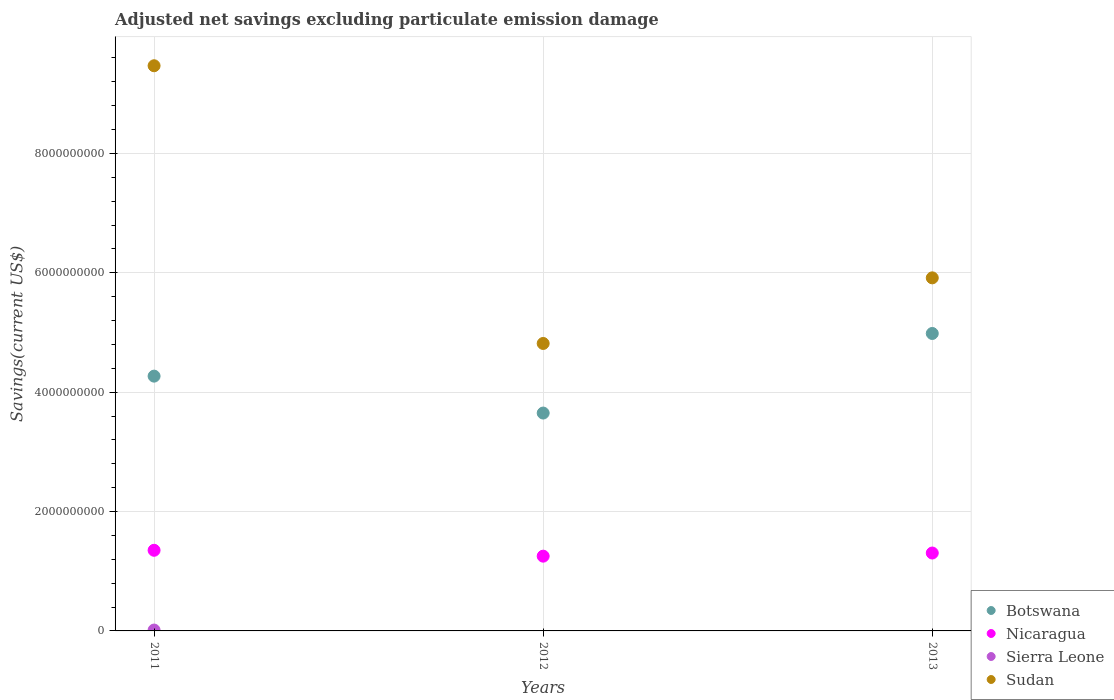How many different coloured dotlines are there?
Ensure brevity in your answer.  4. What is the adjusted net savings in Sierra Leone in 2011?
Offer a very short reply. 1.45e+07. Across all years, what is the maximum adjusted net savings in Sierra Leone?
Your answer should be very brief. 1.45e+07. Across all years, what is the minimum adjusted net savings in Sierra Leone?
Provide a succinct answer. 0. What is the total adjusted net savings in Nicaragua in the graph?
Offer a very short reply. 3.91e+09. What is the difference between the adjusted net savings in Nicaragua in 2011 and that in 2013?
Provide a short and direct response. 4.59e+07. What is the difference between the adjusted net savings in Botswana in 2011 and the adjusted net savings in Sierra Leone in 2013?
Your response must be concise. 4.27e+09. What is the average adjusted net savings in Sierra Leone per year?
Your answer should be compact. 4.82e+06. In the year 2013, what is the difference between the adjusted net savings in Sudan and adjusted net savings in Botswana?
Offer a very short reply. 9.32e+08. What is the ratio of the adjusted net savings in Botswana in 2011 to that in 2012?
Offer a very short reply. 1.17. What is the difference between the highest and the second highest adjusted net savings in Sudan?
Ensure brevity in your answer.  3.55e+09. What is the difference between the highest and the lowest adjusted net savings in Sierra Leone?
Give a very brief answer. 1.45e+07. Is it the case that in every year, the sum of the adjusted net savings in Botswana and adjusted net savings in Sudan  is greater than the sum of adjusted net savings in Sierra Leone and adjusted net savings in Nicaragua?
Offer a terse response. No. Is it the case that in every year, the sum of the adjusted net savings in Sierra Leone and adjusted net savings in Nicaragua  is greater than the adjusted net savings in Botswana?
Offer a very short reply. No. Does the adjusted net savings in Sierra Leone monotonically increase over the years?
Offer a terse response. No. How many dotlines are there?
Your answer should be very brief. 4. How many years are there in the graph?
Your answer should be compact. 3. Does the graph contain any zero values?
Your answer should be very brief. Yes. Does the graph contain grids?
Your response must be concise. Yes. Where does the legend appear in the graph?
Your response must be concise. Bottom right. How are the legend labels stacked?
Provide a succinct answer. Vertical. What is the title of the graph?
Make the answer very short. Adjusted net savings excluding particulate emission damage. Does "Belize" appear as one of the legend labels in the graph?
Your answer should be compact. No. What is the label or title of the X-axis?
Your answer should be very brief. Years. What is the label or title of the Y-axis?
Give a very brief answer. Savings(current US$). What is the Savings(current US$) in Botswana in 2011?
Offer a very short reply. 4.27e+09. What is the Savings(current US$) in Nicaragua in 2011?
Offer a terse response. 1.35e+09. What is the Savings(current US$) of Sierra Leone in 2011?
Offer a very short reply. 1.45e+07. What is the Savings(current US$) of Sudan in 2011?
Offer a very short reply. 9.47e+09. What is the Savings(current US$) of Botswana in 2012?
Your answer should be very brief. 3.65e+09. What is the Savings(current US$) of Nicaragua in 2012?
Keep it short and to the point. 1.25e+09. What is the Savings(current US$) of Sudan in 2012?
Your response must be concise. 4.82e+09. What is the Savings(current US$) of Botswana in 2013?
Keep it short and to the point. 4.98e+09. What is the Savings(current US$) of Nicaragua in 2013?
Offer a very short reply. 1.31e+09. What is the Savings(current US$) in Sudan in 2013?
Your answer should be very brief. 5.91e+09. Across all years, what is the maximum Savings(current US$) of Botswana?
Your response must be concise. 4.98e+09. Across all years, what is the maximum Savings(current US$) in Nicaragua?
Your answer should be compact. 1.35e+09. Across all years, what is the maximum Savings(current US$) of Sierra Leone?
Provide a succinct answer. 1.45e+07. Across all years, what is the maximum Savings(current US$) of Sudan?
Offer a very short reply. 9.47e+09. Across all years, what is the minimum Savings(current US$) of Botswana?
Make the answer very short. 3.65e+09. Across all years, what is the minimum Savings(current US$) in Nicaragua?
Your answer should be very brief. 1.25e+09. Across all years, what is the minimum Savings(current US$) in Sudan?
Offer a terse response. 4.82e+09. What is the total Savings(current US$) of Botswana in the graph?
Provide a succinct answer. 1.29e+1. What is the total Savings(current US$) of Nicaragua in the graph?
Make the answer very short. 3.91e+09. What is the total Savings(current US$) of Sierra Leone in the graph?
Your response must be concise. 1.45e+07. What is the total Savings(current US$) of Sudan in the graph?
Make the answer very short. 2.02e+1. What is the difference between the Savings(current US$) of Botswana in 2011 and that in 2012?
Your answer should be very brief. 6.19e+08. What is the difference between the Savings(current US$) in Nicaragua in 2011 and that in 2012?
Your answer should be compact. 9.85e+07. What is the difference between the Savings(current US$) in Sudan in 2011 and that in 2012?
Provide a short and direct response. 4.65e+09. What is the difference between the Savings(current US$) in Botswana in 2011 and that in 2013?
Give a very brief answer. -7.15e+08. What is the difference between the Savings(current US$) in Nicaragua in 2011 and that in 2013?
Provide a succinct answer. 4.59e+07. What is the difference between the Savings(current US$) in Sudan in 2011 and that in 2013?
Keep it short and to the point. 3.55e+09. What is the difference between the Savings(current US$) of Botswana in 2012 and that in 2013?
Offer a terse response. -1.33e+09. What is the difference between the Savings(current US$) in Nicaragua in 2012 and that in 2013?
Your answer should be very brief. -5.27e+07. What is the difference between the Savings(current US$) of Sudan in 2012 and that in 2013?
Offer a terse response. -1.10e+09. What is the difference between the Savings(current US$) in Botswana in 2011 and the Savings(current US$) in Nicaragua in 2012?
Your answer should be compact. 3.02e+09. What is the difference between the Savings(current US$) of Botswana in 2011 and the Savings(current US$) of Sudan in 2012?
Make the answer very short. -5.47e+08. What is the difference between the Savings(current US$) of Nicaragua in 2011 and the Savings(current US$) of Sudan in 2012?
Offer a terse response. -3.46e+09. What is the difference between the Savings(current US$) in Sierra Leone in 2011 and the Savings(current US$) in Sudan in 2012?
Give a very brief answer. -4.80e+09. What is the difference between the Savings(current US$) in Botswana in 2011 and the Savings(current US$) in Nicaragua in 2013?
Make the answer very short. 2.96e+09. What is the difference between the Savings(current US$) of Botswana in 2011 and the Savings(current US$) of Sudan in 2013?
Make the answer very short. -1.65e+09. What is the difference between the Savings(current US$) in Nicaragua in 2011 and the Savings(current US$) in Sudan in 2013?
Offer a terse response. -4.56e+09. What is the difference between the Savings(current US$) of Sierra Leone in 2011 and the Savings(current US$) of Sudan in 2013?
Give a very brief answer. -5.90e+09. What is the difference between the Savings(current US$) of Botswana in 2012 and the Savings(current US$) of Nicaragua in 2013?
Your answer should be compact. 2.34e+09. What is the difference between the Savings(current US$) of Botswana in 2012 and the Savings(current US$) of Sudan in 2013?
Provide a short and direct response. -2.27e+09. What is the difference between the Savings(current US$) in Nicaragua in 2012 and the Savings(current US$) in Sudan in 2013?
Your answer should be compact. -4.66e+09. What is the average Savings(current US$) in Botswana per year?
Give a very brief answer. 4.30e+09. What is the average Savings(current US$) in Nicaragua per year?
Ensure brevity in your answer.  1.30e+09. What is the average Savings(current US$) in Sierra Leone per year?
Provide a short and direct response. 4.82e+06. What is the average Savings(current US$) of Sudan per year?
Offer a terse response. 6.73e+09. In the year 2011, what is the difference between the Savings(current US$) in Botswana and Savings(current US$) in Nicaragua?
Your answer should be compact. 2.92e+09. In the year 2011, what is the difference between the Savings(current US$) in Botswana and Savings(current US$) in Sierra Leone?
Make the answer very short. 4.25e+09. In the year 2011, what is the difference between the Savings(current US$) of Botswana and Savings(current US$) of Sudan?
Provide a short and direct response. -5.20e+09. In the year 2011, what is the difference between the Savings(current US$) in Nicaragua and Savings(current US$) in Sierra Leone?
Make the answer very short. 1.34e+09. In the year 2011, what is the difference between the Savings(current US$) in Nicaragua and Savings(current US$) in Sudan?
Make the answer very short. -8.12e+09. In the year 2011, what is the difference between the Savings(current US$) in Sierra Leone and Savings(current US$) in Sudan?
Offer a very short reply. -9.45e+09. In the year 2012, what is the difference between the Savings(current US$) in Botswana and Savings(current US$) in Nicaragua?
Ensure brevity in your answer.  2.40e+09. In the year 2012, what is the difference between the Savings(current US$) of Botswana and Savings(current US$) of Sudan?
Offer a terse response. -1.17e+09. In the year 2012, what is the difference between the Savings(current US$) of Nicaragua and Savings(current US$) of Sudan?
Provide a succinct answer. -3.56e+09. In the year 2013, what is the difference between the Savings(current US$) of Botswana and Savings(current US$) of Nicaragua?
Your answer should be very brief. 3.68e+09. In the year 2013, what is the difference between the Savings(current US$) in Botswana and Savings(current US$) in Sudan?
Provide a short and direct response. -9.32e+08. In the year 2013, what is the difference between the Savings(current US$) of Nicaragua and Savings(current US$) of Sudan?
Your response must be concise. -4.61e+09. What is the ratio of the Savings(current US$) in Botswana in 2011 to that in 2012?
Your answer should be very brief. 1.17. What is the ratio of the Savings(current US$) in Nicaragua in 2011 to that in 2012?
Your response must be concise. 1.08. What is the ratio of the Savings(current US$) of Sudan in 2011 to that in 2012?
Offer a terse response. 1.97. What is the ratio of the Savings(current US$) of Botswana in 2011 to that in 2013?
Provide a succinct answer. 0.86. What is the ratio of the Savings(current US$) of Nicaragua in 2011 to that in 2013?
Your answer should be compact. 1.04. What is the ratio of the Savings(current US$) in Sudan in 2011 to that in 2013?
Make the answer very short. 1.6. What is the ratio of the Savings(current US$) of Botswana in 2012 to that in 2013?
Your response must be concise. 0.73. What is the ratio of the Savings(current US$) of Nicaragua in 2012 to that in 2013?
Make the answer very short. 0.96. What is the ratio of the Savings(current US$) in Sudan in 2012 to that in 2013?
Offer a terse response. 0.81. What is the difference between the highest and the second highest Savings(current US$) of Botswana?
Your answer should be very brief. 7.15e+08. What is the difference between the highest and the second highest Savings(current US$) of Nicaragua?
Your answer should be compact. 4.59e+07. What is the difference between the highest and the second highest Savings(current US$) of Sudan?
Your answer should be compact. 3.55e+09. What is the difference between the highest and the lowest Savings(current US$) in Botswana?
Your answer should be compact. 1.33e+09. What is the difference between the highest and the lowest Savings(current US$) in Nicaragua?
Give a very brief answer. 9.85e+07. What is the difference between the highest and the lowest Savings(current US$) in Sierra Leone?
Your answer should be compact. 1.45e+07. What is the difference between the highest and the lowest Savings(current US$) in Sudan?
Your response must be concise. 4.65e+09. 